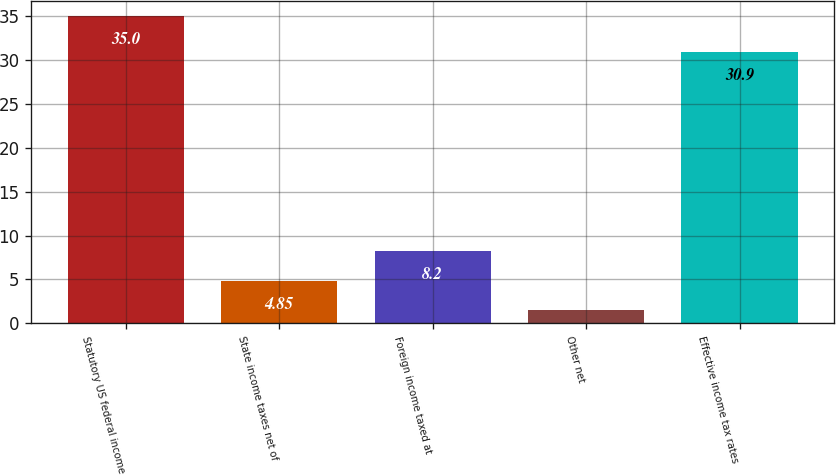<chart> <loc_0><loc_0><loc_500><loc_500><bar_chart><fcel>Statutory US federal income<fcel>State income taxes net of<fcel>Foreign income taxed at<fcel>Other net<fcel>Effective income tax rates<nl><fcel>35<fcel>4.85<fcel>8.2<fcel>1.5<fcel>30.9<nl></chart> 